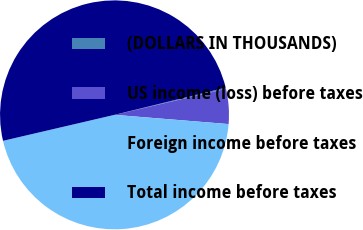Convert chart to OTSL. <chart><loc_0><loc_0><loc_500><loc_500><pie_chart><fcel>(DOLLARS IN THOUSANDS)<fcel>US income (loss) before taxes<fcel>Foreign income before taxes<fcel>Total income before taxes<nl><fcel>0.18%<fcel>4.93%<fcel>45.07%<fcel>49.82%<nl></chart> 